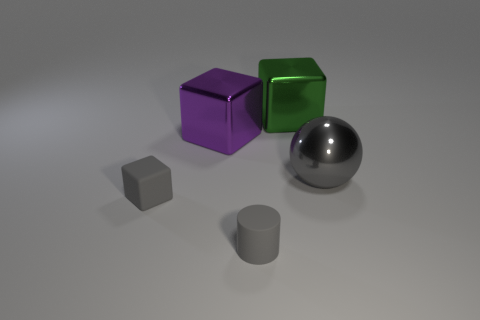How many big blocks are there?
Provide a short and direct response. 2. What color is the other metallic cube that is the same size as the purple block?
Your answer should be very brief. Green. Is the cube in front of the gray metallic object made of the same material as the small cylinder that is in front of the purple metallic thing?
Provide a short and direct response. Yes. What size is the cube that is to the right of the big cube in front of the big green metal block?
Your answer should be very brief. Large. There is a big thing that is on the left side of the cylinder; what is it made of?
Keep it short and to the point. Metal. How many objects are big metal things that are in front of the purple object or tiny gray matte things that are in front of the tiny block?
Your answer should be compact. 2. There is another big thing that is the same shape as the purple metallic thing; what is its material?
Provide a succinct answer. Metal. There is a small thing that is to the right of the big purple metal cube; is it the same color as the block that is in front of the large gray ball?
Keep it short and to the point. Yes. Is there a gray rubber cylinder of the same size as the rubber cube?
Your answer should be compact. Yes. The thing that is both right of the gray cylinder and left of the big ball is made of what material?
Your response must be concise. Metal. 